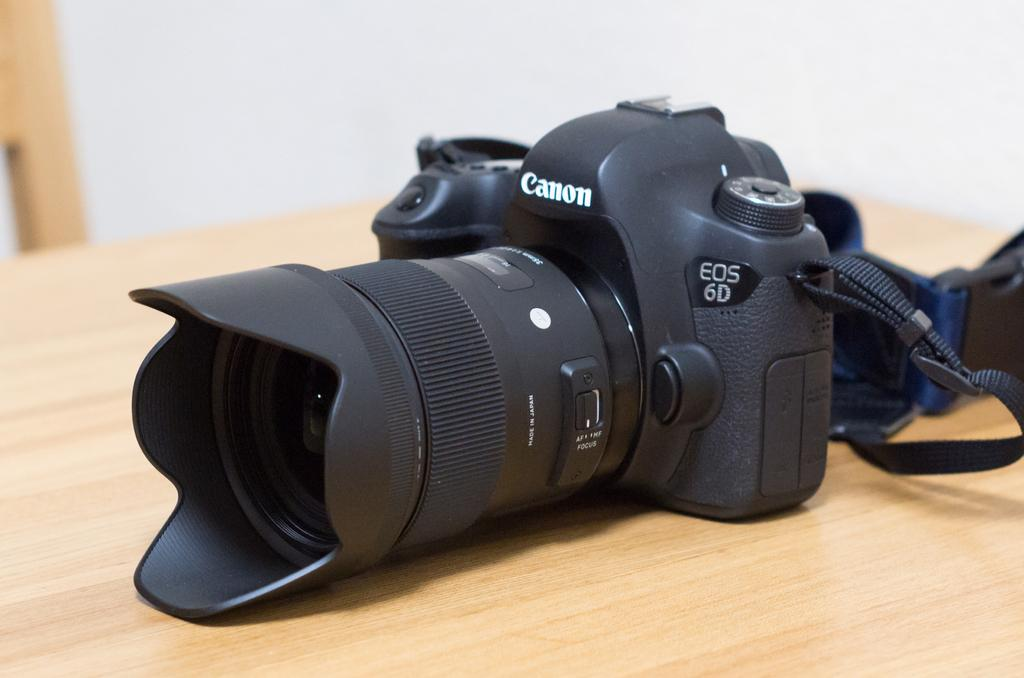What is the main object on the table in the image? There is a camera on the table in the image. What can be seen in the background of the image? There is an object visible in the background of the image, and there is also a wall. Can you describe the object in the background? Unfortunately, the facts provided do not give enough information to describe the object in the background. What type of button is being distributed during the battle in the image? There is no button, distribution, or battle present in the image. 